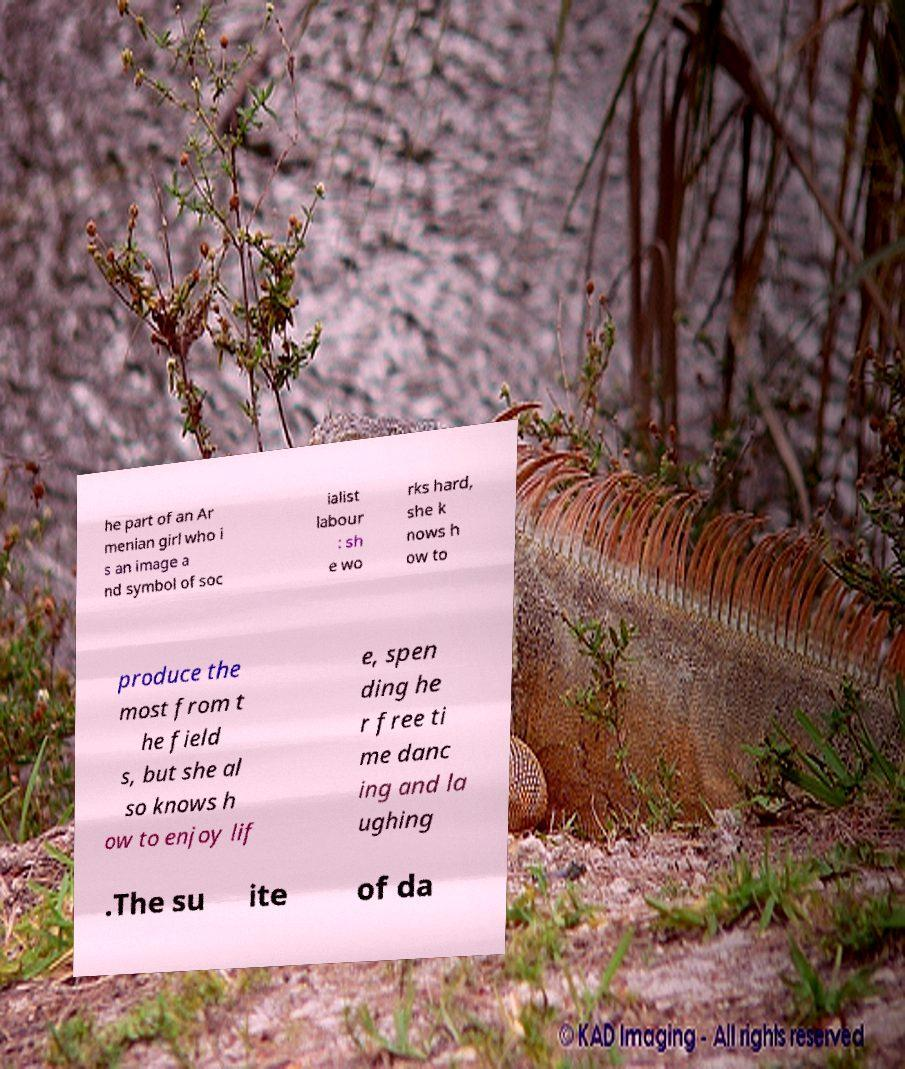What messages or text are displayed in this image? I need them in a readable, typed format. he part of an Ar menian girl who i s an image a nd symbol of soc ialist labour : sh e wo rks hard, she k nows h ow to produce the most from t he field s, but she al so knows h ow to enjoy lif e, spen ding he r free ti me danc ing and la ughing .The su ite of da 